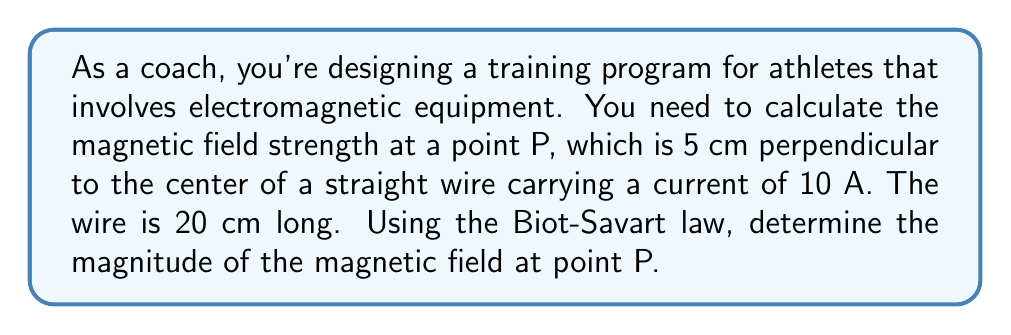Show me your answer to this math problem. Let's approach this step-by-step using the Biot-Savart law:

1) The Biot-Savart law for a finite straight wire is given by:

   $$B = \frac{\mu_0 I}{4\pi r} (\sin\theta_1 + \sin\theta_2)$$

   where $\mu_0 = 4\pi \times 10^{-7}$ T⋅m/A is the permeability of free space, $I$ is the current, $r$ is the perpendicular distance from the wire to the point, and $\theta_1$ and $\theta_2$ are the angles from the ends of the wire to the perpendicular line.

2) Given:
   - Current, $I = 10$ A
   - Wire length, $L = 20$ cm = 0.2 m
   - Distance to point P, $r = 5$ cm = 0.05 m

3) We need to find $\theta_1$ and $\theta_2$:

   [asy]
   import geometry;
   
   size(200);
   
   draw((-50,0)--(50,0),Arrow);
   draw((0,-10)--(0,50),Arrow);
   
   dot((0,40),red);
   label("P",(0,45),N);
   
   draw((-40,0)--(40,0),blue,Arrows);
   label("Wire",(0,-5),S);
   
   draw((0,0)--(0,40),dashed);
   draw((-40,0)--(0,40),dashed);
   draw((40,0)--(0,40),dashed);
   
   label("$r$",(2,20),E);
   label("$L/2$",(20,0),S);
   label("$\theta_1$",(-15,15),NW);
   label("$\theta_2$",(15,15),NE);
   [/asy]

   $$\tan\theta_1 = \tan\theta_2 = \frac{L/2}{r} = \frac{0.1}{0.05} = 2$$
   $$\theta_1 = \theta_2 = \arctan(2) = 1.107 \text{ rad}$$

4) Now we can calculate the magnetic field:

   $$\begin{align}
   B &= \frac{\mu_0 I}{4\pi r} (\sin\theta_1 + \sin\theta_2) \\
   &= \frac{(4\pi \times 10^{-7})(10)}{4\pi(0.05)} (2\sin(1.107)) \\
   &= \frac{10^{-6}}{0.05} (2 \times 0.8944) \\
   &= 2 \times 10^{-5} \times 1.7888 \\
   &= 3.5776 \times 10^{-5} \text{ T}
   \end{align}$$

5) Rounding to three significant figures:

   $$B \approx 3.58 \times 10^{-5} \text{ T}$$
Answer: $3.58 \times 10^{-5}$ T 